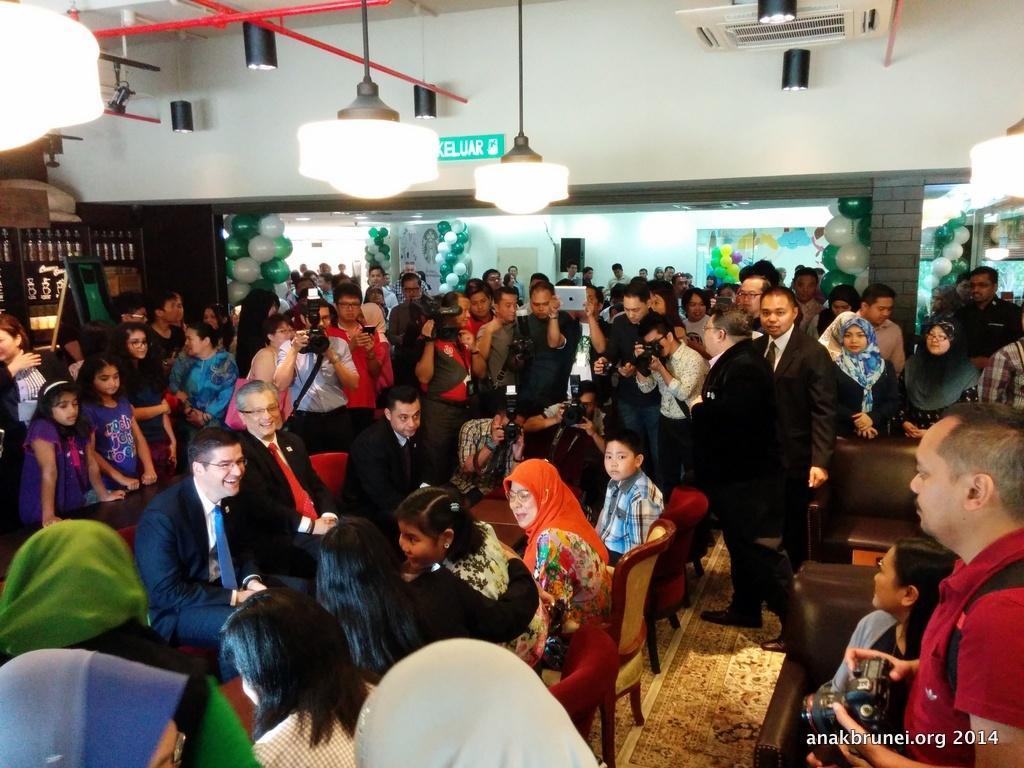Can you describe this image briefly? In this picture I can observe some people sitting on the chairs. Some of them are standing on the floor. I can observe man, woman and children in this picture. In the top of the picture I can observe three lights hanging to the ceiling. In the background there are balloons and a wall. 